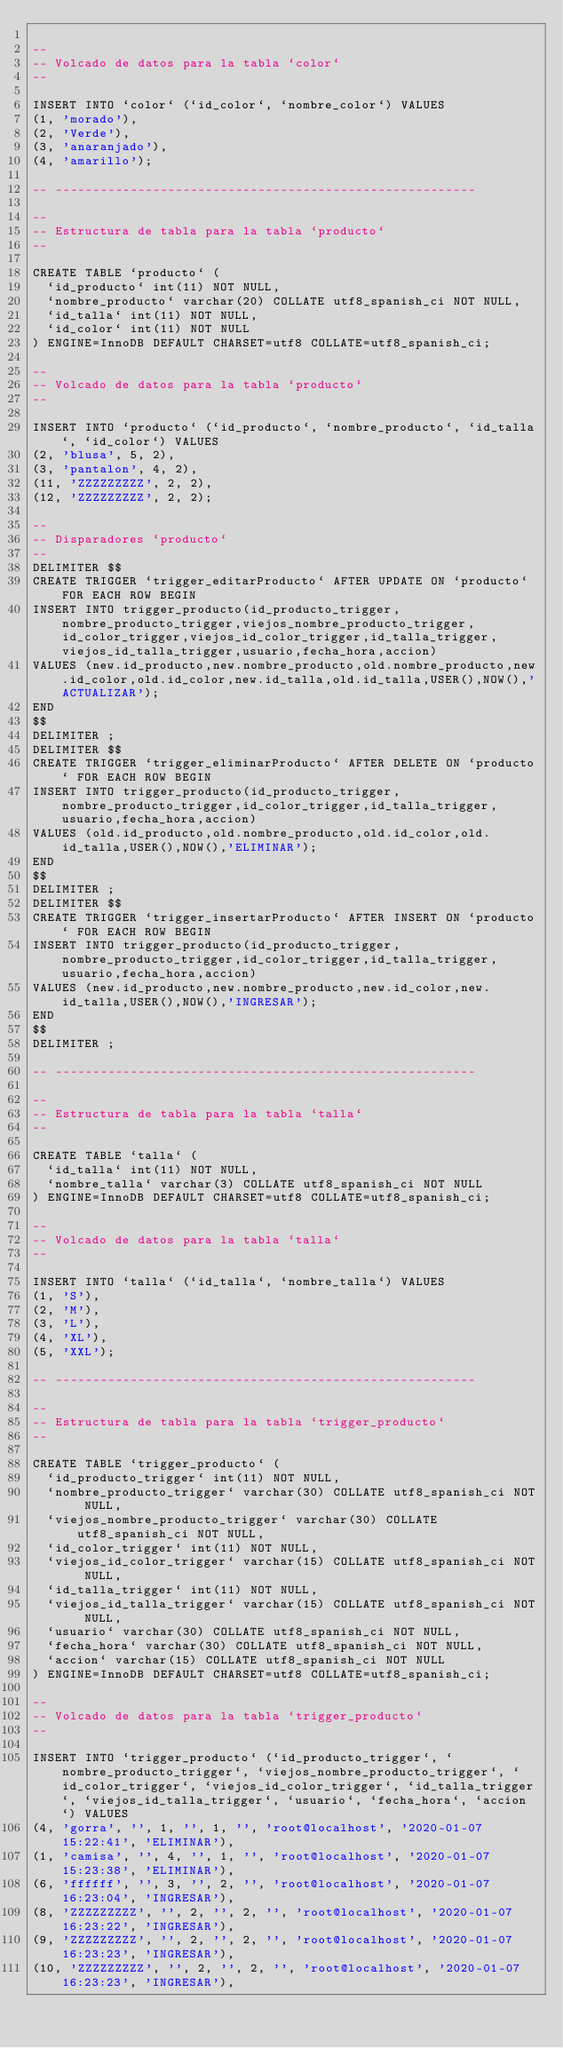Convert code to text. <code><loc_0><loc_0><loc_500><loc_500><_SQL_>
--
-- Volcado de datos para la tabla `color`
--

INSERT INTO `color` (`id_color`, `nombre_color`) VALUES
(1, 'morado'),
(2, 'Verde'),
(3, 'anaranjado'),
(4, 'amarillo');

-- --------------------------------------------------------

--
-- Estructura de tabla para la tabla `producto`
--

CREATE TABLE `producto` (
  `id_producto` int(11) NOT NULL,
  `nombre_producto` varchar(20) COLLATE utf8_spanish_ci NOT NULL,
  `id_talla` int(11) NOT NULL,
  `id_color` int(11) NOT NULL
) ENGINE=InnoDB DEFAULT CHARSET=utf8 COLLATE=utf8_spanish_ci;

--
-- Volcado de datos para la tabla `producto`
--

INSERT INTO `producto` (`id_producto`, `nombre_producto`, `id_talla`, `id_color`) VALUES
(2, 'blusa', 5, 2),
(3, 'pantalon', 4, 2),
(11, 'ZZZZZZZZZ', 2, 2),
(12, 'ZZZZZZZZZ', 2, 2);

--
-- Disparadores `producto`
--
DELIMITER $$
CREATE TRIGGER `trigger_editarProducto` AFTER UPDATE ON `producto` FOR EACH ROW BEGIN
INSERT INTO trigger_producto(id_producto_trigger,nombre_producto_trigger,viejos_nombre_producto_trigger,id_color_trigger,viejos_id_color_trigger,id_talla_trigger,viejos_id_talla_trigger,usuario,fecha_hora,accion)
VALUES (new.id_producto,new.nombre_producto,old.nombre_producto,new.id_color,old.id_color,new.id_talla,old.id_talla,USER(),NOW(),'ACTUALIZAR');
END
$$
DELIMITER ;
DELIMITER $$
CREATE TRIGGER `trigger_eliminarProducto` AFTER DELETE ON `producto` FOR EACH ROW BEGIN
INSERT INTO trigger_producto(id_producto_trigger,nombre_producto_trigger,id_color_trigger,id_talla_trigger,usuario,fecha_hora,accion)
VALUES (old.id_producto,old.nombre_producto,old.id_color,old.id_talla,USER(),NOW(),'ELIMINAR');
END
$$
DELIMITER ;
DELIMITER $$
CREATE TRIGGER `trigger_insertarProducto` AFTER INSERT ON `producto` FOR EACH ROW BEGIN
INSERT INTO trigger_producto(id_producto_trigger,nombre_producto_trigger,id_color_trigger,id_talla_trigger,usuario,fecha_hora,accion)
VALUES (new.id_producto,new.nombre_producto,new.id_color,new.id_talla,USER(),NOW(),'INGRESAR');
END
$$
DELIMITER ;

-- --------------------------------------------------------

--
-- Estructura de tabla para la tabla `talla`
--

CREATE TABLE `talla` (
  `id_talla` int(11) NOT NULL,
  `nombre_talla` varchar(3) COLLATE utf8_spanish_ci NOT NULL
) ENGINE=InnoDB DEFAULT CHARSET=utf8 COLLATE=utf8_spanish_ci;

--
-- Volcado de datos para la tabla `talla`
--

INSERT INTO `talla` (`id_talla`, `nombre_talla`) VALUES
(1, 'S'),
(2, 'M'),
(3, 'L'),
(4, 'XL'),
(5, 'XXL');

-- --------------------------------------------------------

--
-- Estructura de tabla para la tabla `trigger_producto`
--

CREATE TABLE `trigger_producto` (
  `id_producto_trigger` int(11) NOT NULL,
  `nombre_producto_trigger` varchar(30) COLLATE utf8_spanish_ci NOT NULL,
  `viejos_nombre_producto_trigger` varchar(30) COLLATE utf8_spanish_ci NOT NULL,
  `id_color_trigger` int(11) NOT NULL,
  `viejos_id_color_trigger` varchar(15) COLLATE utf8_spanish_ci NOT NULL,
  `id_talla_trigger` int(11) NOT NULL,
  `viejos_id_talla_trigger` varchar(15) COLLATE utf8_spanish_ci NOT NULL,
  `usuario` varchar(30) COLLATE utf8_spanish_ci NOT NULL,
  `fecha_hora` varchar(30) COLLATE utf8_spanish_ci NOT NULL,
  `accion` varchar(15) COLLATE utf8_spanish_ci NOT NULL
) ENGINE=InnoDB DEFAULT CHARSET=utf8 COLLATE=utf8_spanish_ci;

--
-- Volcado de datos para la tabla `trigger_producto`
--

INSERT INTO `trigger_producto` (`id_producto_trigger`, `nombre_producto_trigger`, `viejos_nombre_producto_trigger`, `id_color_trigger`, `viejos_id_color_trigger`, `id_talla_trigger`, `viejos_id_talla_trigger`, `usuario`, `fecha_hora`, `accion`) VALUES
(4, 'gorra', '', 1, '', 1, '', 'root@localhost', '2020-01-07 15:22:41', 'ELIMINAR'),
(1, 'camisa', '', 4, '', 1, '', 'root@localhost', '2020-01-07 15:23:38', 'ELIMINAR'),
(6, 'ffffff', '', 3, '', 2, '', 'root@localhost', '2020-01-07 16:23:04', 'INGRESAR'),
(8, 'ZZZZZZZZZ', '', 2, '', 2, '', 'root@localhost', '2020-01-07 16:23:22', 'INGRESAR'),
(9, 'ZZZZZZZZZ', '', 2, '', 2, '', 'root@localhost', '2020-01-07 16:23:23', 'INGRESAR'),
(10, 'ZZZZZZZZZ', '', 2, '', 2, '', 'root@localhost', '2020-01-07 16:23:23', 'INGRESAR'),</code> 